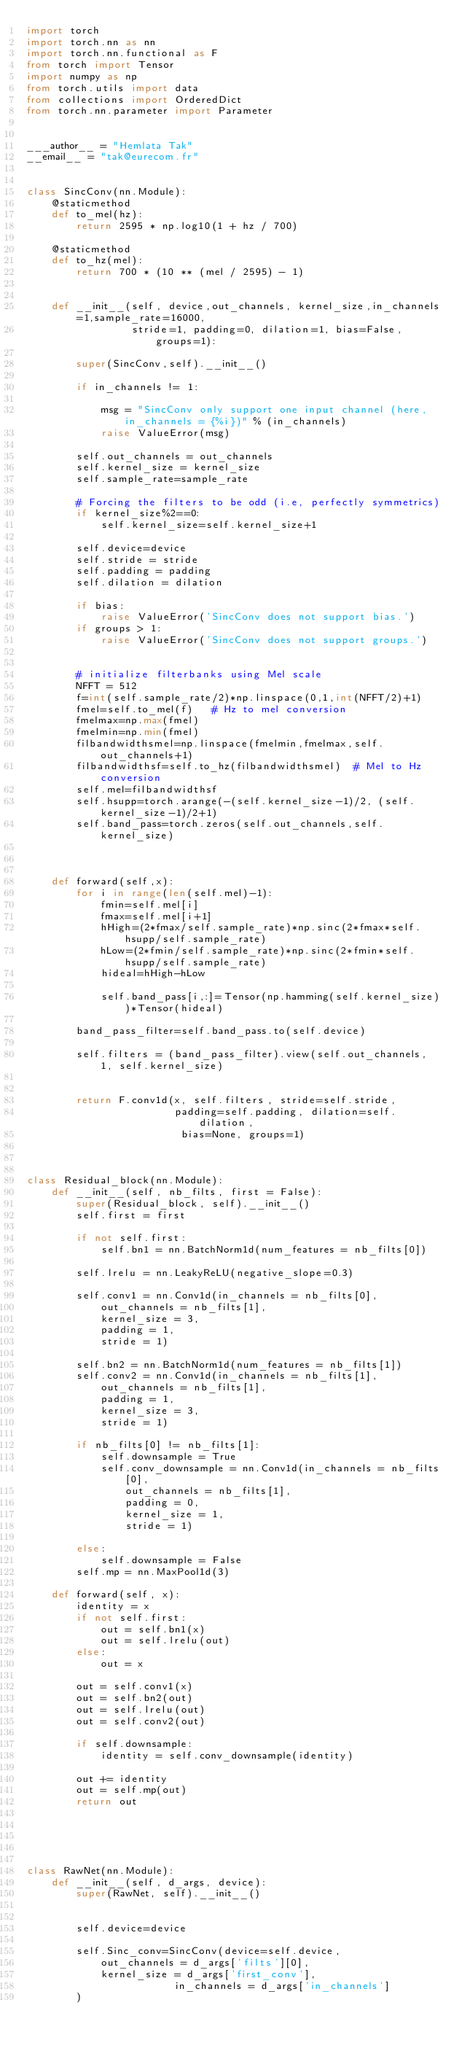<code> <loc_0><loc_0><loc_500><loc_500><_Python_>import torch
import torch.nn as nn
import torch.nn.functional as F
from torch import Tensor
import numpy as np
from torch.utils import data
from collections import OrderedDict
from torch.nn.parameter import Parameter


___author__ = "Hemlata Tak"
__email__ = "tak@eurecom.fr"


class SincConv(nn.Module):
    @staticmethod
    def to_mel(hz):
        return 2595 * np.log10(1 + hz / 700)

    @staticmethod
    def to_hz(mel):
        return 700 * (10 ** (mel / 2595) - 1)


    def __init__(self, device,out_channels, kernel_size,in_channels=1,sample_rate=16000,
                 stride=1, padding=0, dilation=1, bias=False, groups=1):

        super(SincConv,self).__init__()

        if in_channels != 1:
            
            msg = "SincConv only support one input channel (here, in_channels = {%i})" % (in_channels)
            raise ValueError(msg)
        
        self.out_channels = out_channels
        self.kernel_size = kernel_size
        self.sample_rate=sample_rate

        # Forcing the filters to be odd (i.e, perfectly symmetrics)
        if kernel_size%2==0:
            self.kernel_size=self.kernel_size+1

        self.device=device   
        self.stride = stride
        self.padding = padding
        self.dilation = dilation
        
        if bias:
            raise ValueError('SincConv does not support bias.')
        if groups > 1:
            raise ValueError('SincConv does not support groups.')
        
        
        # initialize filterbanks using Mel scale
        NFFT = 512
        f=int(self.sample_rate/2)*np.linspace(0,1,int(NFFT/2)+1)
        fmel=self.to_mel(f)   # Hz to mel conversion
        fmelmax=np.max(fmel)
        fmelmin=np.min(fmel)
        filbandwidthsmel=np.linspace(fmelmin,fmelmax,self.out_channels+1)
        filbandwidthsf=self.to_hz(filbandwidthsmel)  # Mel to Hz conversion
        self.mel=filbandwidthsf
        self.hsupp=torch.arange(-(self.kernel_size-1)/2, (self.kernel_size-1)/2+1)
        self.band_pass=torch.zeros(self.out_channels,self.kernel_size)
    
       
        
    def forward(self,x):
        for i in range(len(self.mel)-1):
            fmin=self.mel[i]
            fmax=self.mel[i+1]
            hHigh=(2*fmax/self.sample_rate)*np.sinc(2*fmax*self.hsupp/self.sample_rate)
            hLow=(2*fmin/self.sample_rate)*np.sinc(2*fmin*self.hsupp/self.sample_rate)
            hideal=hHigh-hLow
            
            self.band_pass[i,:]=Tensor(np.hamming(self.kernel_size))*Tensor(hideal)
        
        band_pass_filter=self.band_pass.to(self.device)

        self.filters = (band_pass_filter).view(self.out_channels, 1, self.kernel_size)
                 

        return F.conv1d(x, self.filters, stride=self.stride,
                        padding=self.padding, dilation=self.dilation,
                         bias=None, groups=1)


        
class Residual_block(nn.Module):
    def __init__(self, nb_filts, first = False):
        super(Residual_block, self).__init__()
        self.first = first
        
        if not self.first:
            self.bn1 = nn.BatchNorm1d(num_features = nb_filts[0])
        
        self.lrelu = nn.LeakyReLU(negative_slope=0.3)
        
        self.conv1 = nn.Conv1d(in_channels = nb_filts[0],
			out_channels = nb_filts[1],
			kernel_size = 3,
			padding = 1,
			stride = 1)
        
        self.bn2 = nn.BatchNorm1d(num_features = nb_filts[1])
        self.conv2 = nn.Conv1d(in_channels = nb_filts[1],
			out_channels = nb_filts[1],
			padding = 1,
			kernel_size = 3,
			stride = 1)
        
        if nb_filts[0] != nb_filts[1]:
            self.downsample = True
            self.conv_downsample = nn.Conv1d(in_channels = nb_filts[0],
				out_channels = nb_filts[1],
				padding = 0,
				kernel_size = 1,
				stride = 1)
            
        else:
            self.downsample = False
        self.mp = nn.MaxPool1d(3)
        
    def forward(self, x):
        identity = x
        if not self.first:
            out = self.bn1(x)
            out = self.lrelu(out)
        else:
            out = x
            
        out = self.conv1(x)
        out = self.bn2(out)
        out = self.lrelu(out)
        out = self.conv2(out)
        
        if self.downsample:
            identity = self.conv_downsample(identity)
            
        out += identity
        out = self.mp(out)
        return out





class RawNet(nn.Module):
    def __init__(self, d_args, device):
        super(RawNet, self).__init__()

        
        self.device=device

        self.Sinc_conv=SincConv(device=self.device,
			out_channels = d_args['filts'][0],
			kernel_size = d_args['first_conv'],
                        in_channels = d_args['in_channels']
        )
        </code> 